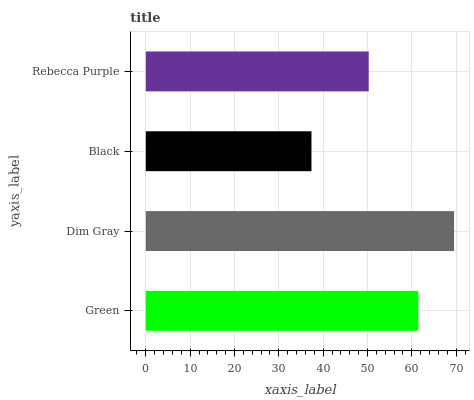Is Black the minimum?
Answer yes or no. Yes. Is Dim Gray the maximum?
Answer yes or no. Yes. Is Dim Gray the minimum?
Answer yes or no. No. Is Black the maximum?
Answer yes or no. No. Is Dim Gray greater than Black?
Answer yes or no. Yes. Is Black less than Dim Gray?
Answer yes or no. Yes. Is Black greater than Dim Gray?
Answer yes or no. No. Is Dim Gray less than Black?
Answer yes or no. No. Is Green the high median?
Answer yes or no. Yes. Is Rebecca Purple the low median?
Answer yes or no. Yes. Is Dim Gray the high median?
Answer yes or no. No. Is Green the low median?
Answer yes or no. No. 